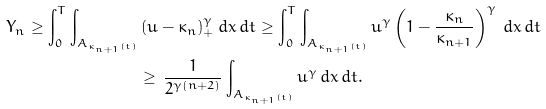Convert formula to latex. <formula><loc_0><loc_0><loc_500><loc_500>Y _ { n } \geq \int _ { 0 } ^ { T } \int _ { A _ { \kappa _ { n + 1 } ( t ) } } & \, ( u - \kappa _ { n } ) _ { + } ^ { \gamma } \, d x \, d t \geq \int _ { 0 } ^ { T } \int _ { A _ { \kappa _ { n + 1 } ( t ) } } u ^ { \gamma } \left ( 1 - \frac { \kappa _ { n } } { \kappa _ { n + 1 } } \right ) ^ { \gamma } \, d x \, d t \\ & \geq \, \frac { 1 } { 2 ^ { \gamma ( n + 2 ) } } \int _ { A _ { \kappa _ { n + 1 } ( t ) } } u ^ { \gamma } \, d x \, d t .</formula> 